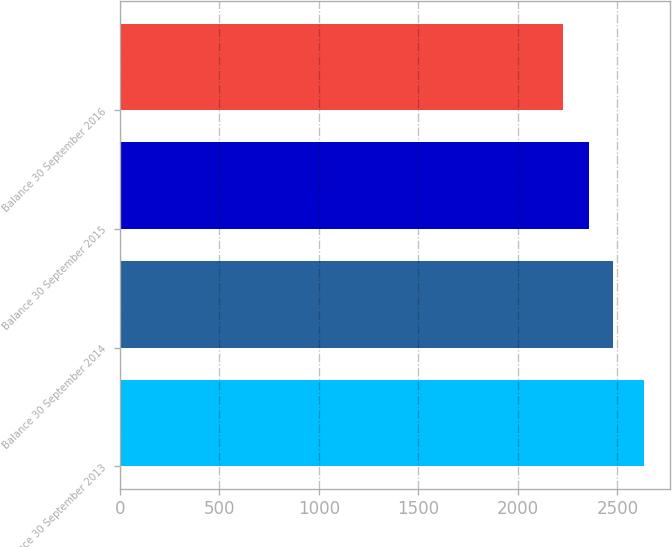Convert chart to OTSL. <chart><loc_0><loc_0><loc_500><loc_500><bar_chart><fcel>Balance 30 September 2013<fcel>Balance 30 September 2014<fcel>Balance 30 September 2015<fcel>Balance 30 September 2016<nl><fcel>2632.3<fcel>2476.9<fcel>2359.6<fcel>2227<nl></chart> 